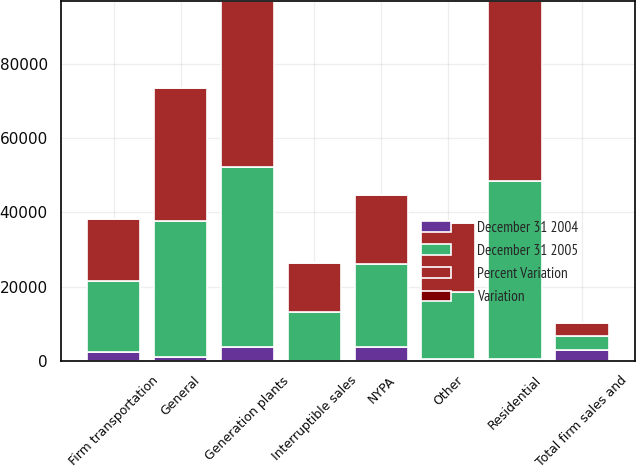Convert chart to OTSL. <chart><loc_0><loc_0><loc_500><loc_500><stacked_bar_chart><ecel><fcel>Residential<fcel>General<fcel>Firm transportation<fcel>Total firm sales and<fcel>Interruptible sales<fcel>NYPA<fcel>Generation plants<fcel>Other<nl><fcel>December 31 2005<fcel>48175<fcel>36800<fcel>19088<fcel>3737<fcel>13128<fcel>22305<fcel>48564<fcel>18103<nl><fcel>Percent Variation<fcel>48569<fcel>35887<fcel>16795<fcel>3737<fcel>13187<fcel>18623<fcel>44772<fcel>18534<nl><fcel>December 31 2004<fcel>394<fcel>913<fcel>2293<fcel>2812<fcel>59<fcel>3682<fcel>3792<fcel>431<nl><fcel>Variation<fcel>0.8<fcel>2.5<fcel>13.7<fcel>2.8<fcel>0.4<fcel>19.8<fcel>8.5<fcel>2.3<nl></chart> 